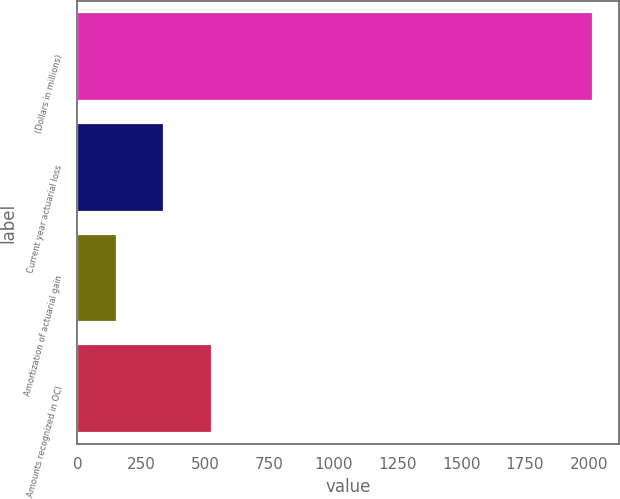Convert chart to OTSL. <chart><loc_0><loc_0><loc_500><loc_500><bar_chart><fcel>(Dollars in millions)<fcel>Current year actuarial loss<fcel>Amortization of actuarial gain<fcel>Amounts recognized in OCI<nl><fcel>2017<fcel>340.3<fcel>154<fcel>526.6<nl></chart> 